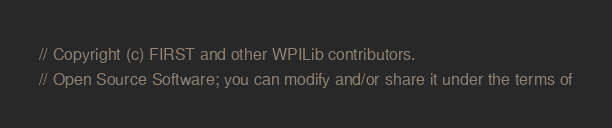<code> <loc_0><loc_0><loc_500><loc_500><_C++_>// Copyright (c) FIRST and other WPILib contributors.
// Open Source Software; you can modify and/or share it under the terms of</code> 